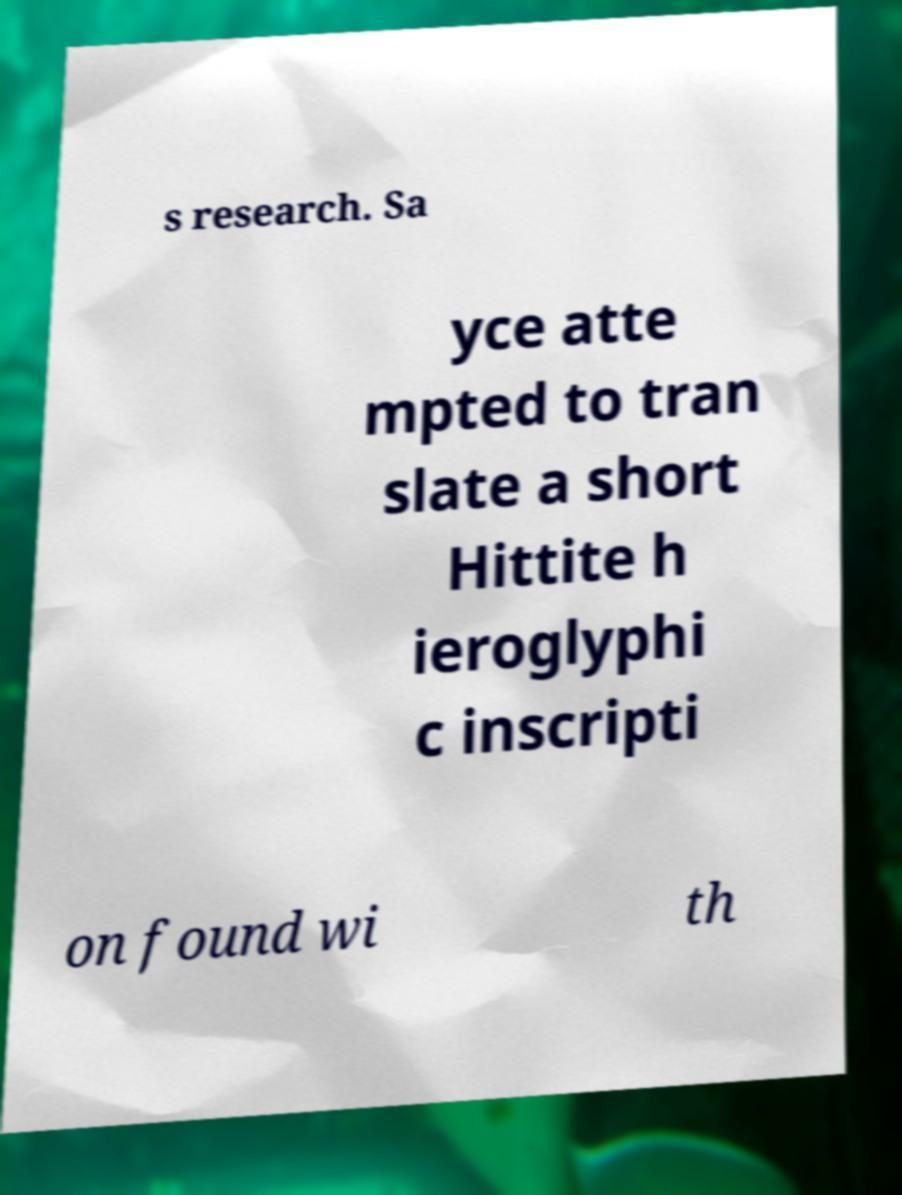Could you extract and type out the text from this image? s research. Sa yce atte mpted to tran slate a short Hittite h ieroglyphi c inscripti on found wi th 